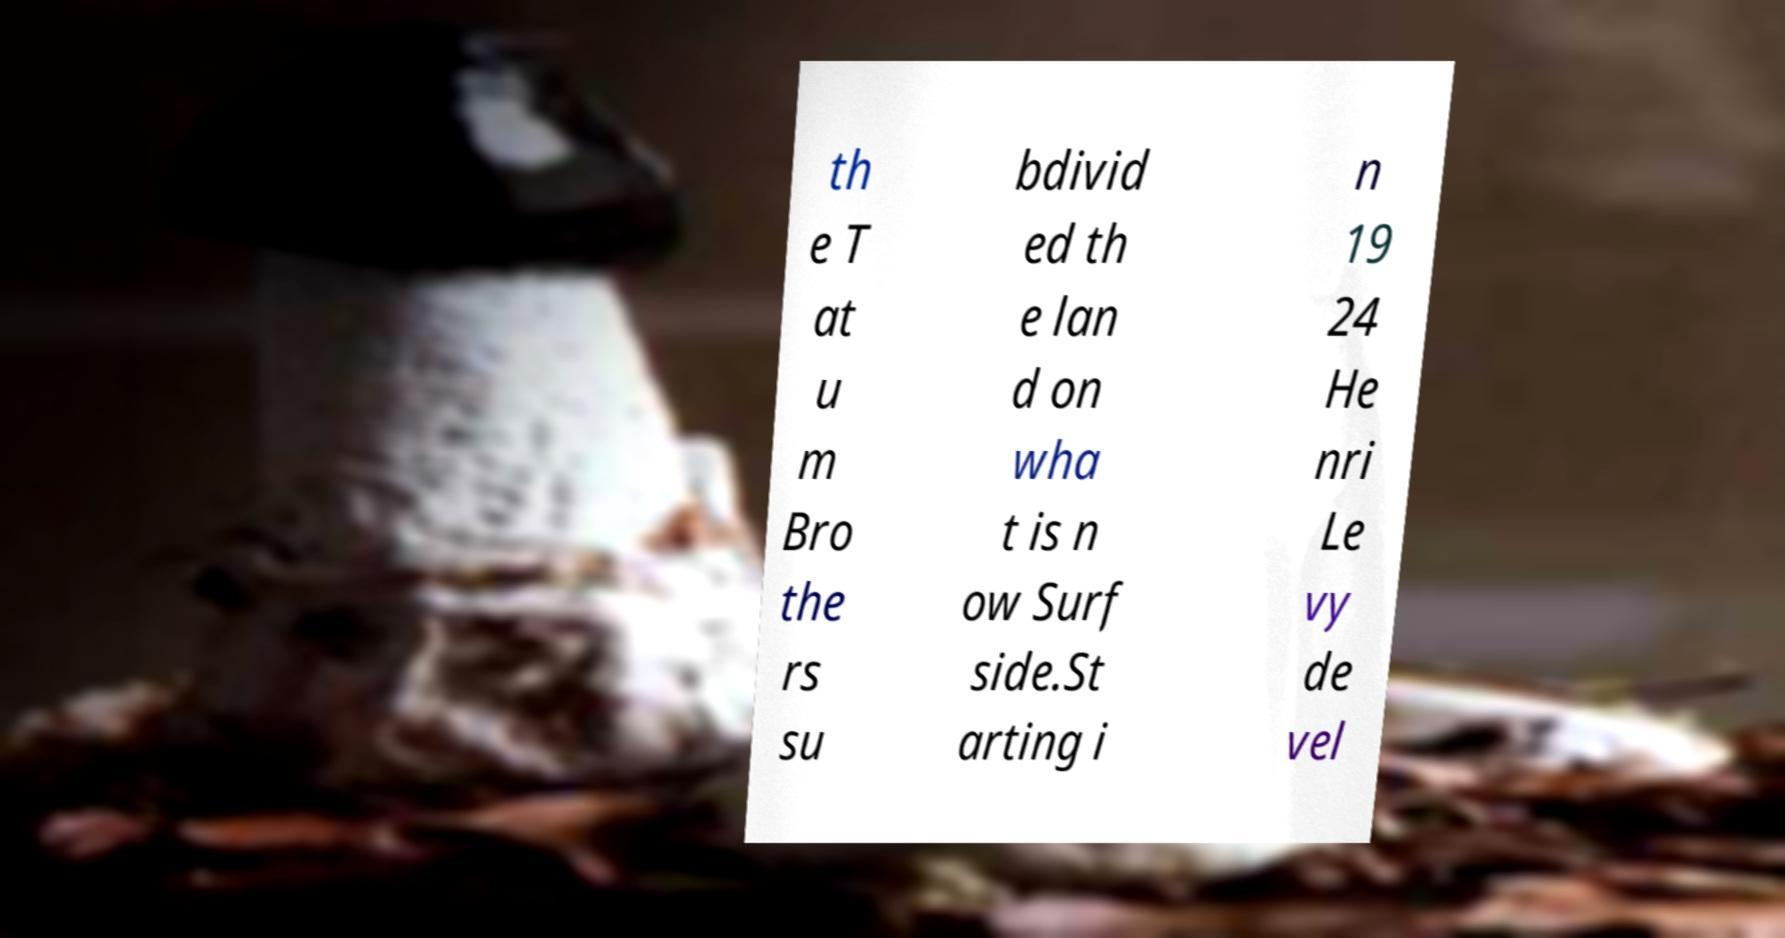Please identify and transcribe the text found in this image. th e T at u m Bro the rs su bdivid ed th e lan d on wha t is n ow Surf side.St arting i n 19 24 He nri Le vy de vel 